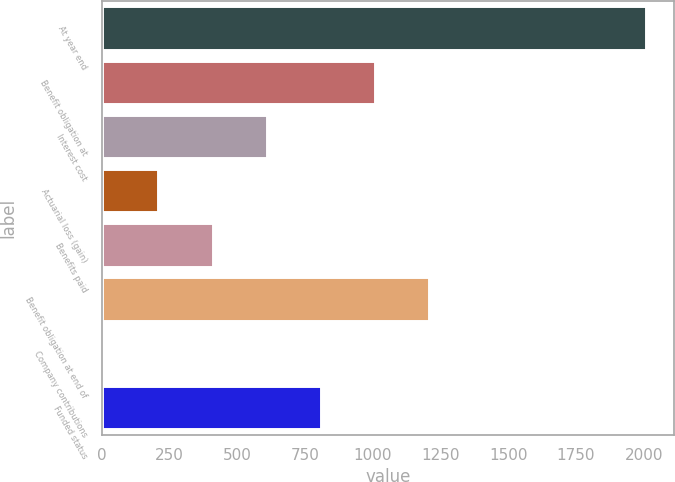Convert chart to OTSL. <chart><loc_0><loc_0><loc_500><loc_500><bar_chart><fcel>At year end<fcel>Benefit obligation at<fcel>Interest cost<fcel>Actuarial loss (gain)<fcel>Benefits paid<fcel>Benefit obligation at end of<fcel>Company contributions<fcel>Funded status<nl><fcel>2010<fcel>1009<fcel>608.6<fcel>208.2<fcel>408.4<fcel>1209.2<fcel>8<fcel>808.8<nl></chart> 